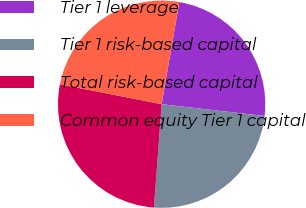<chart> <loc_0><loc_0><loc_500><loc_500><pie_chart><fcel>Tier 1 leverage<fcel>Tier 1 risk-based capital<fcel>Total risk-based capital<fcel>Common equity Tier 1 capital<nl><fcel>24.08%<fcel>24.37%<fcel>26.9%<fcel>24.65%<nl></chart> 